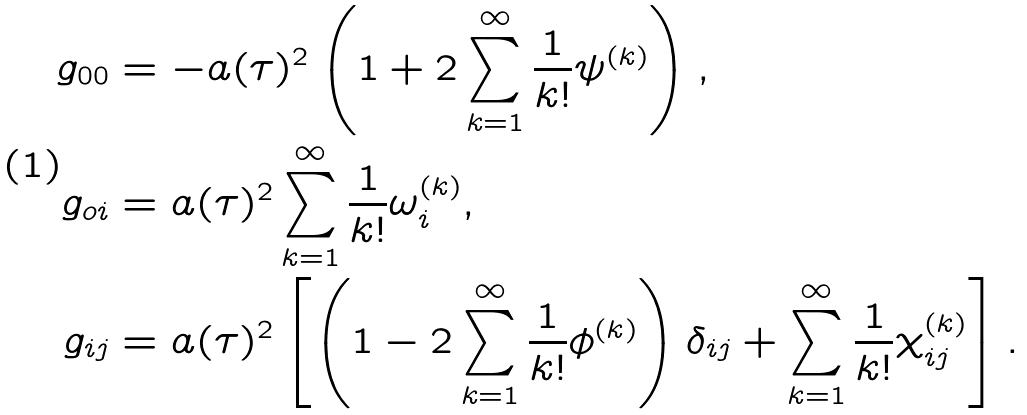Convert formula to latex. <formula><loc_0><loc_0><loc_500><loc_500>g _ { 0 0 } & = - a ( \tau ) ^ { 2 } \left ( 1 + 2 \sum _ { k = 1 } ^ { \infty } \frac { 1 } { k ! } \psi ^ { ( k ) } \right ) , \\ g _ { o i } & = a ( \tau ) ^ { 2 } \sum _ { k = 1 } ^ { \infty } \frac { 1 } { k ! } \omega _ { i } ^ { ( k ) } , \\ g _ { i j } & = a ( \tau ) ^ { 2 } \left [ \left ( 1 - 2 \sum _ { k = 1 } ^ { \infty } \frac { 1 } { k ! } \phi ^ { ( k ) } \right ) \delta _ { i j } + \sum _ { k = 1 } ^ { \infty } \frac { 1 } { k ! } \chi _ { i j } ^ { ( k ) } \right ] .</formula> 